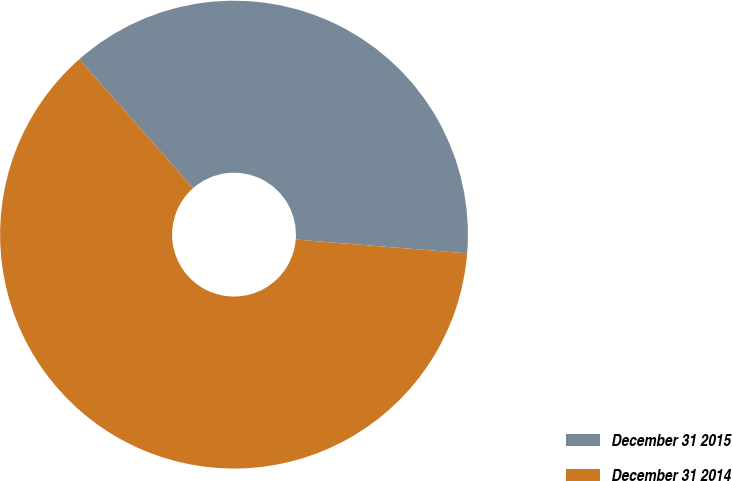Convert chart. <chart><loc_0><loc_0><loc_500><loc_500><pie_chart><fcel>December 31 2015<fcel>December 31 2014<nl><fcel>37.78%<fcel>62.22%<nl></chart> 